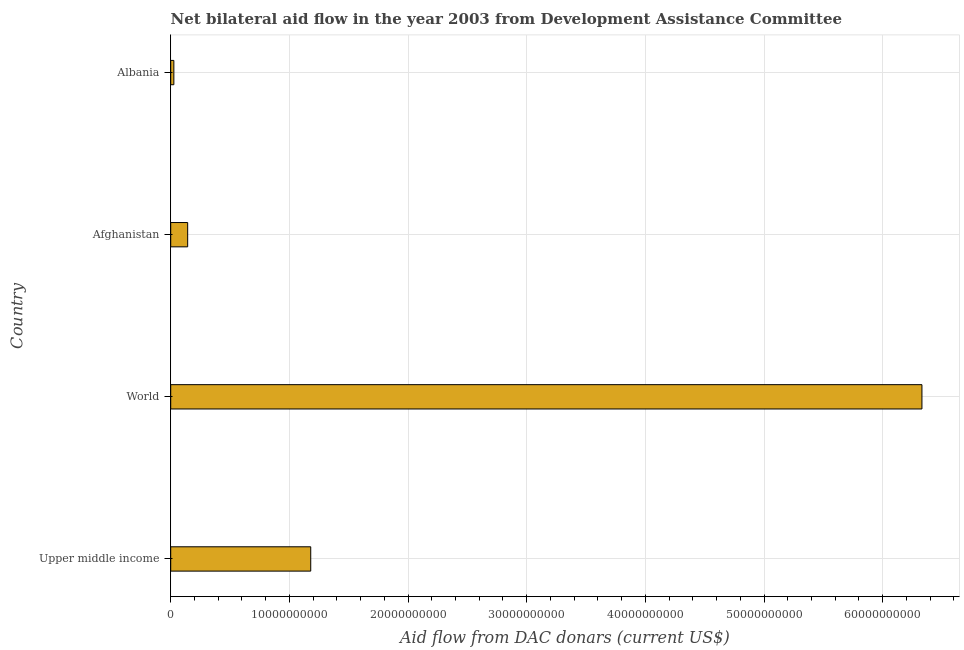Does the graph contain any zero values?
Your answer should be compact. No. Does the graph contain grids?
Provide a short and direct response. Yes. What is the title of the graph?
Provide a succinct answer. Net bilateral aid flow in the year 2003 from Development Assistance Committee. What is the label or title of the X-axis?
Make the answer very short. Aid flow from DAC donars (current US$). What is the label or title of the Y-axis?
Give a very brief answer. Country. What is the net bilateral aid flows from dac donors in Upper middle income?
Give a very brief answer. 1.18e+1. Across all countries, what is the maximum net bilateral aid flows from dac donors?
Your answer should be very brief. 6.33e+1. Across all countries, what is the minimum net bilateral aid flows from dac donors?
Your response must be concise. 2.64e+08. In which country was the net bilateral aid flows from dac donors maximum?
Provide a short and direct response. World. In which country was the net bilateral aid flows from dac donors minimum?
Offer a very short reply. Albania. What is the sum of the net bilateral aid flows from dac donors?
Offer a terse response. 7.68e+1. What is the difference between the net bilateral aid flows from dac donors in Albania and Upper middle income?
Offer a very short reply. -1.15e+1. What is the average net bilateral aid flows from dac donors per country?
Your answer should be compact. 1.92e+1. What is the median net bilateral aid flows from dac donors?
Your response must be concise. 6.61e+09. In how many countries, is the net bilateral aid flows from dac donors greater than 64000000000 US$?
Provide a succinct answer. 0. What is the ratio of the net bilateral aid flows from dac donors in Afghanistan to that in World?
Offer a terse response. 0.02. Is the difference between the net bilateral aid flows from dac donors in Afghanistan and Albania greater than the difference between any two countries?
Your response must be concise. No. What is the difference between the highest and the second highest net bilateral aid flows from dac donors?
Make the answer very short. 5.15e+1. What is the difference between the highest and the lowest net bilateral aid flows from dac donors?
Give a very brief answer. 6.30e+1. In how many countries, is the net bilateral aid flows from dac donors greater than the average net bilateral aid flows from dac donors taken over all countries?
Keep it short and to the point. 1. Are the values on the major ticks of X-axis written in scientific E-notation?
Your response must be concise. No. What is the Aid flow from DAC donars (current US$) of Upper middle income?
Give a very brief answer. 1.18e+1. What is the Aid flow from DAC donars (current US$) of World?
Provide a succinct answer. 6.33e+1. What is the Aid flow from DAC donars (current US$) of Afghanistan?
Your answer should be compact. 1.43e+09. What is the Aid flow from DAC donars (current US$) in Albania?
Give a very brief answer. 2.64e+08. What is the difference between the Aid flow from DAC donars (current US$) in Upper middle income and World?
Ensure brevity in your answer.  -5.15e+1. What is the difference between the Aid flow from DAC donars (current US$) in Upper middle income and Afghanistan?
Provide a short and direct response. 1.04e+1. What is the difference between the Aid flow from DAC donars (current US$) in Upper middle income and Albania?
Offer a very short reply. 1.15e+1. What is the difference between the Aid flow from DAC donars (current US$) in World and Afghanistan?
Your answer should be very brief. 6.19e+1. What is the difference between the Aid flow from DAC donars (current US$) in World and Albania?
Provide a short and direct response. 6.30e+1. What is the difference between the Aid flow from DAC donars (current US$) in Afghanistan and Albania?
Provide a succinct answer. 1.16e+09. What is the ratio of the Aid flow from DAC donars (current US$) in Upper middle income to that in World?
Your answer should be very brief. 0.19. What is the ratio of the Aid flow from DAC donars (current US$) in Upper middle income to that in Afghanistan?
Your answer should be very brief. 8.26. What is the ratio of the Aid flow from DAC donars (current US$) in Upper middle income to that in Albania?
Make the answer very short. 44.65. What is the ratio of the Aid flow from DAC donars (current US$) in World to that in Afghanistan?
Your answer should be compact. 44.3. What is the ratio of the Aid flow from DAC donars (current US$) in World to that in Albania?
Ensure brevity in your answer.  239.53. What is the ratio of the Aid flow from DAC donars (current US$) in Afghanistan to that in Albania?
Provide a succinct answer. 5.41. 